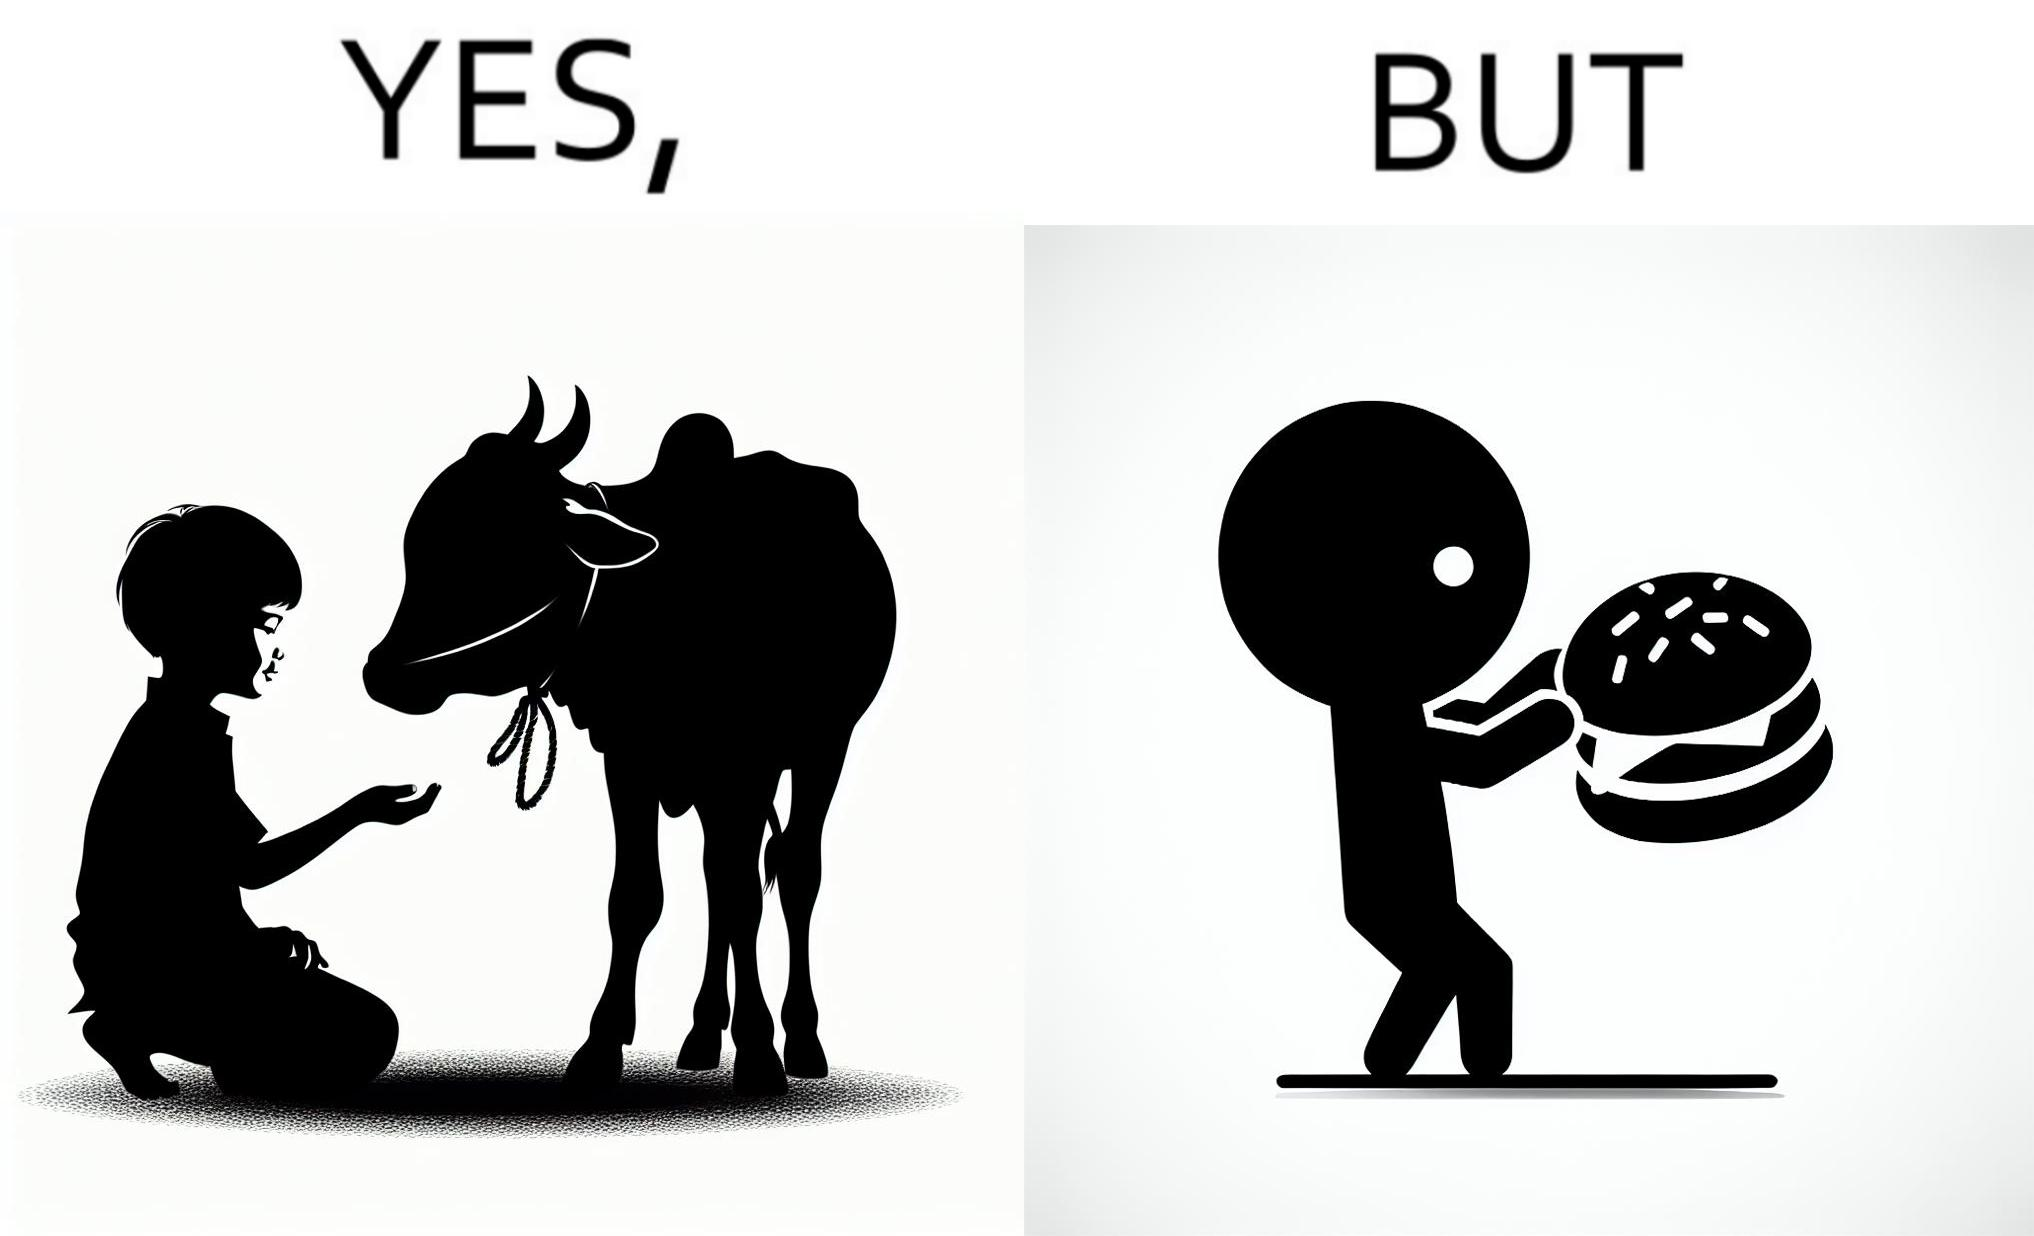What do you see in each half of this image? In the left part of the image: A boy petting a cow In the right part of the image: A boy eating a hamburger 